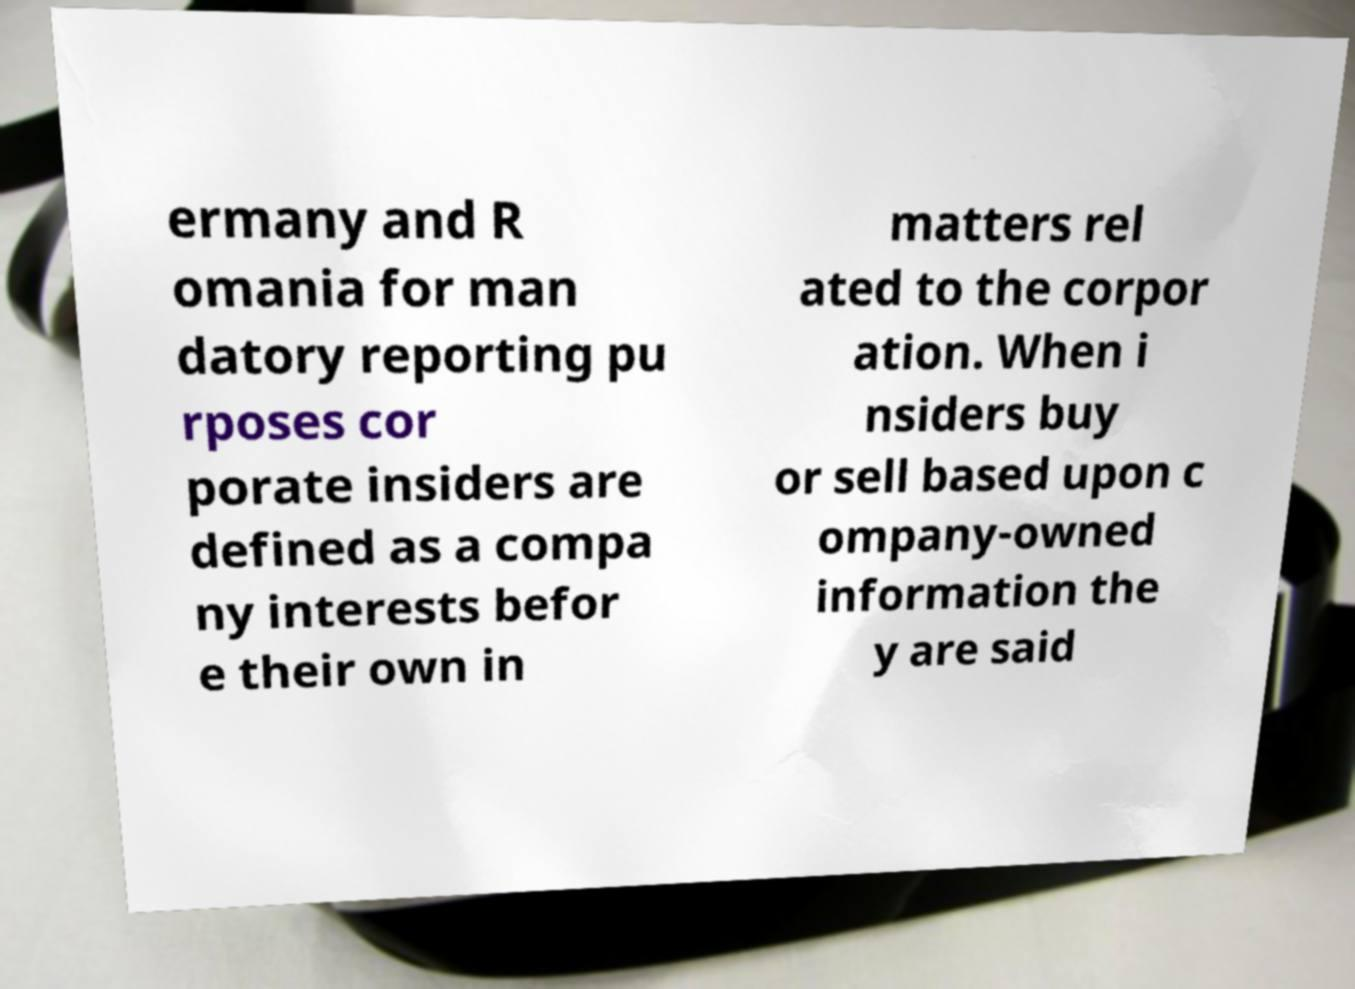Can you accurately transcribe the text from the provided image for me? ermany and R omania for man datory reporting pu rposes cor porate insiders are defined as a compa ny interests befor e their own in matters rel ated to the corpor ation. When i nsiders buy or sell based upon c ompany-owned information the y are said 